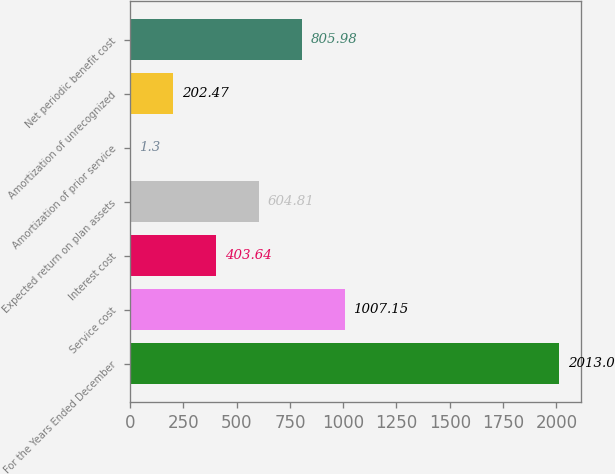<chart> <loc_0><loc_0><loc_500><loc_500><bar_chart><fcel>For the Years Ended December<fcel>Service cost<fcel>Interest cost<fcel>Expected return on plan assets<fcel>Amortization of prior service<fcel>Amortization of unrecognized<fcel>Net periodic benefit cost<nl><fcel>2013<fcel>1007.15<fcel>403.64<fcel>604.81<fcel>1.3<fcel>202.47<fcel>805.98<nl></chart> 